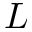Convert formula to latex. <formula><loc_0><loc_0><loc_500><loc_500>L</formula> 